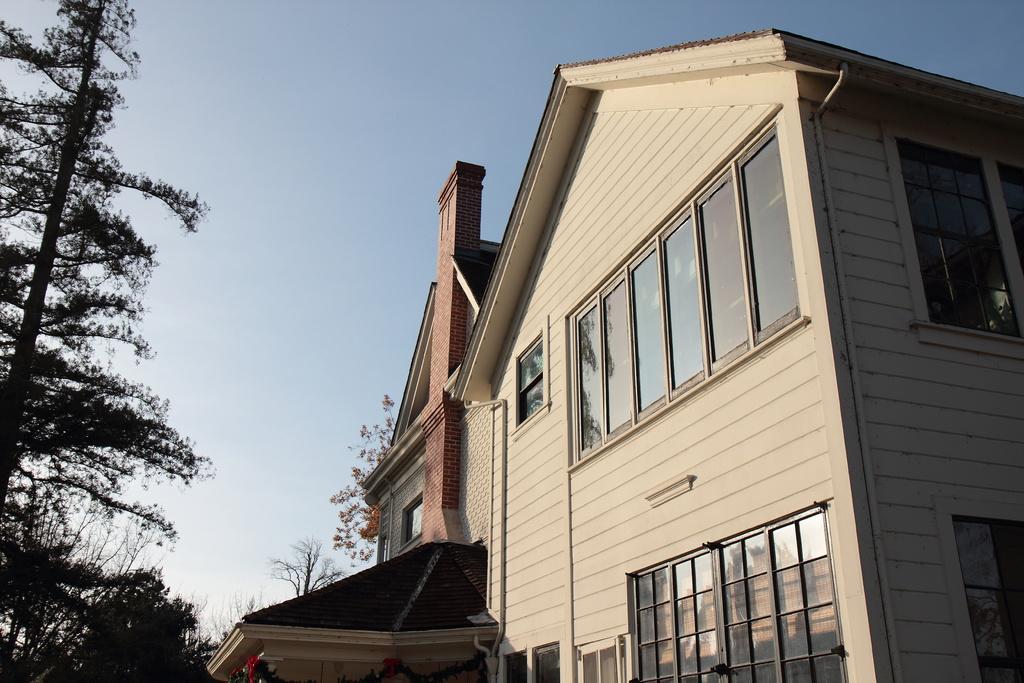Describe this image in one or two sentences. In this picture I can see a building with windows, there are trees, and in the background there is the sky. 